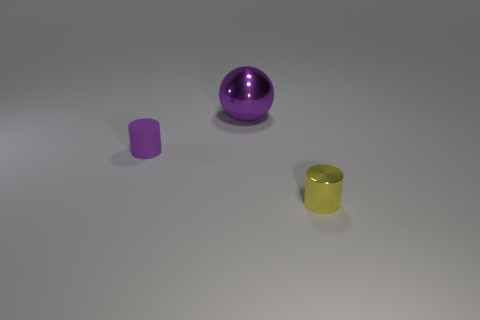Add 2 large purple metallic objects. How many objects exist? 5 Subtract 1 cylinders. How many cylinders are left? 1 Subtract all spheres. How many objects are left? 2 Add 3 small brown metallic cylinders. How many small brown metallic cylinders exist? 3 Subtract 0 cyan cylinders. How many objects are left? 3 Subtract all brown cylinders. Subtract all cyan blocks. How many cylinders are left? 2 Subtract all purple balls. How many purple cylinders are left? 1 Subtract all large metal objects. Subtract all tiny blue metal balls. How many objects are left? 2 Add 1 large purple metal balls. How many large purple metal balls are left? 2 